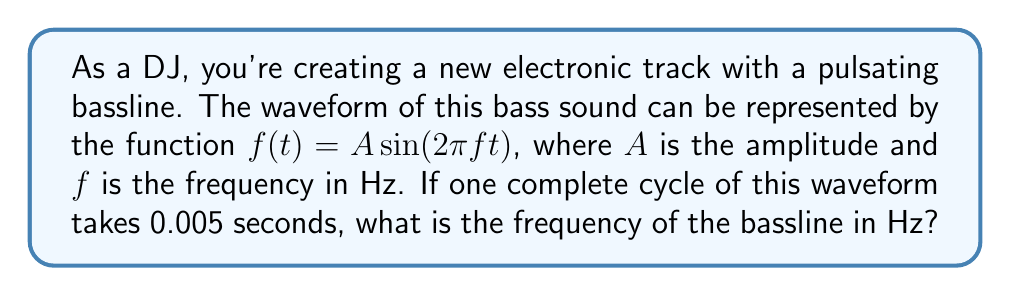What is the answer to this math problem? Let's approach this step-by-step:

1) The general form of a sine wave is:

   $f(t) = A \sin(2\pi ft)$

   where $f$ is the frequency in Hz.

2) We know that one complete cycle takes 0.005 seconds. This is the period (T) of the wave.

3) The relationship between frequency and period is:

   $f = \frac{1}{T}$

4) Substituting our known value:

   $f = \frac{1}{0.005}$

5) Calculating:

   $f = 200$ Hz

6) We can verify this by considering that in 1 second, there would be:

   $\frac{1}{0.005} = 200$ complete cycles

Therefore, the frequency of the bassline is 200 Hz.
Answer: 200 Hz 